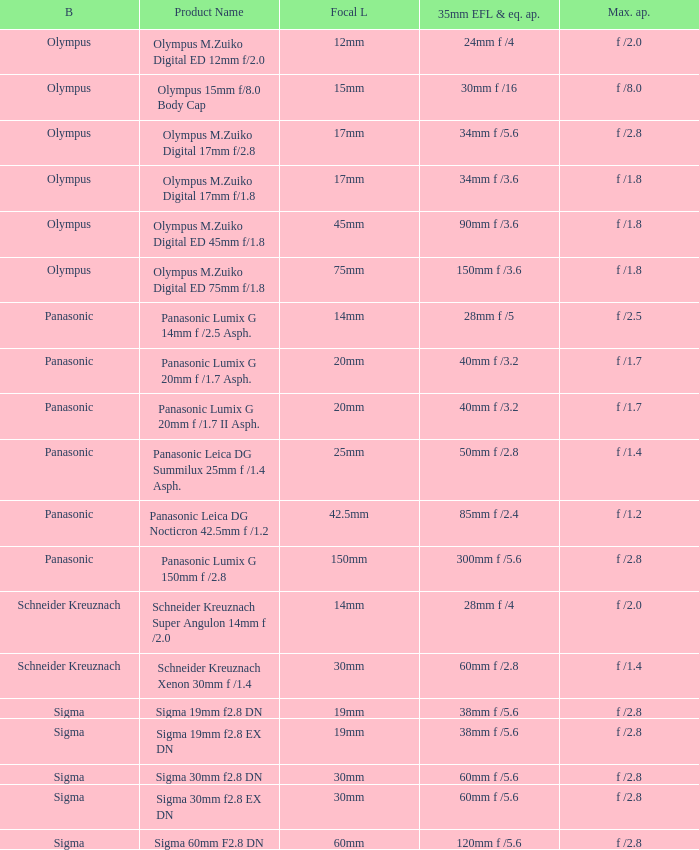What is the 35mm EFL and the equivalent aperture of the lens(es) with a maximum aperture of f /2.5? 28mm f /5. 